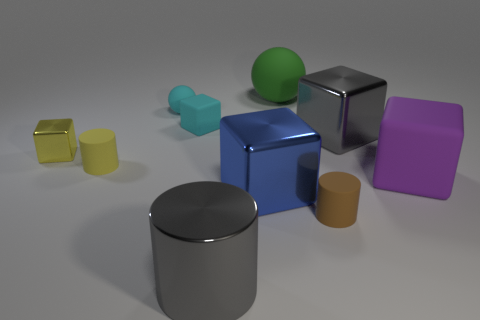Is the number of metallic objects that are to the right of the small yellow metallic object less than the number of tiny red metallic objects?
Offer a terse response. No. Is there a blue thing that is in front of the small matte cylinder that is behind the cylinder on the right side of the green sphere?
Offer a terse response. Yes. Is the material of the blue cube the same as the big gray object that is behind the blue block?
Your response must be concise. Yes. What is the color of the metallic cube that is to the left of the gray shiny object in front of the tiny yellow matte cylinder?
Ensure brevity in your answer.  Yellow. Is there a tiny rubber block that has the same color as the tiny rubber sphere?
Offer a terse response. Yes. There is a gray object behind the yellow thing to the left of the tiny cylinder that is left of the big gray shiny cylinder; what size is it?
Keep it short and to the point. Large. Is the shape of the big blue metallic thing the same as the big matte object left of the large gray block?
Your answer should be very brief. No. How many other objects are there of the same size as the purple matte object?
Your response must be concise. 4. How big is the matte cylinder to the right of the cyan sphere?
Keep it short and to the point. Small. What number of cyan spheres have the same material as the large green object?
Your answer should be very brief. 1. 